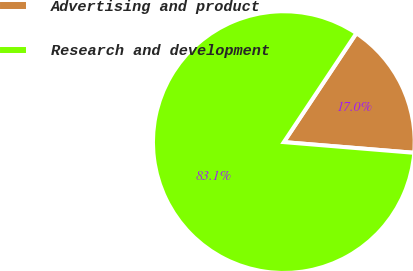Convert chart to OTSL. <chart><loc_0><loc_0><loc_500><loc_500><pie_chart><fcel>Advertising and product<fcel>Research and development<nl><fcel>16.95%<fcel>83.05%<nl></chart> 